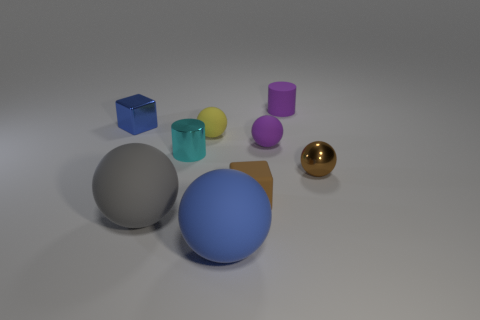Add 1 big gray things. How many objects exist? 10 Subtract all cubes. How many objects are left? 7 Subtract 1 gray spheres. How many objects are left? 8 Subtract all tiny green shiny cubes. Subtract all gray matte spheres. How many objects are left? 8 Add 4 big objects. How many big objects are left? 6 Add 6 tiny cylinders. How many tiny cylinders exist? 8 